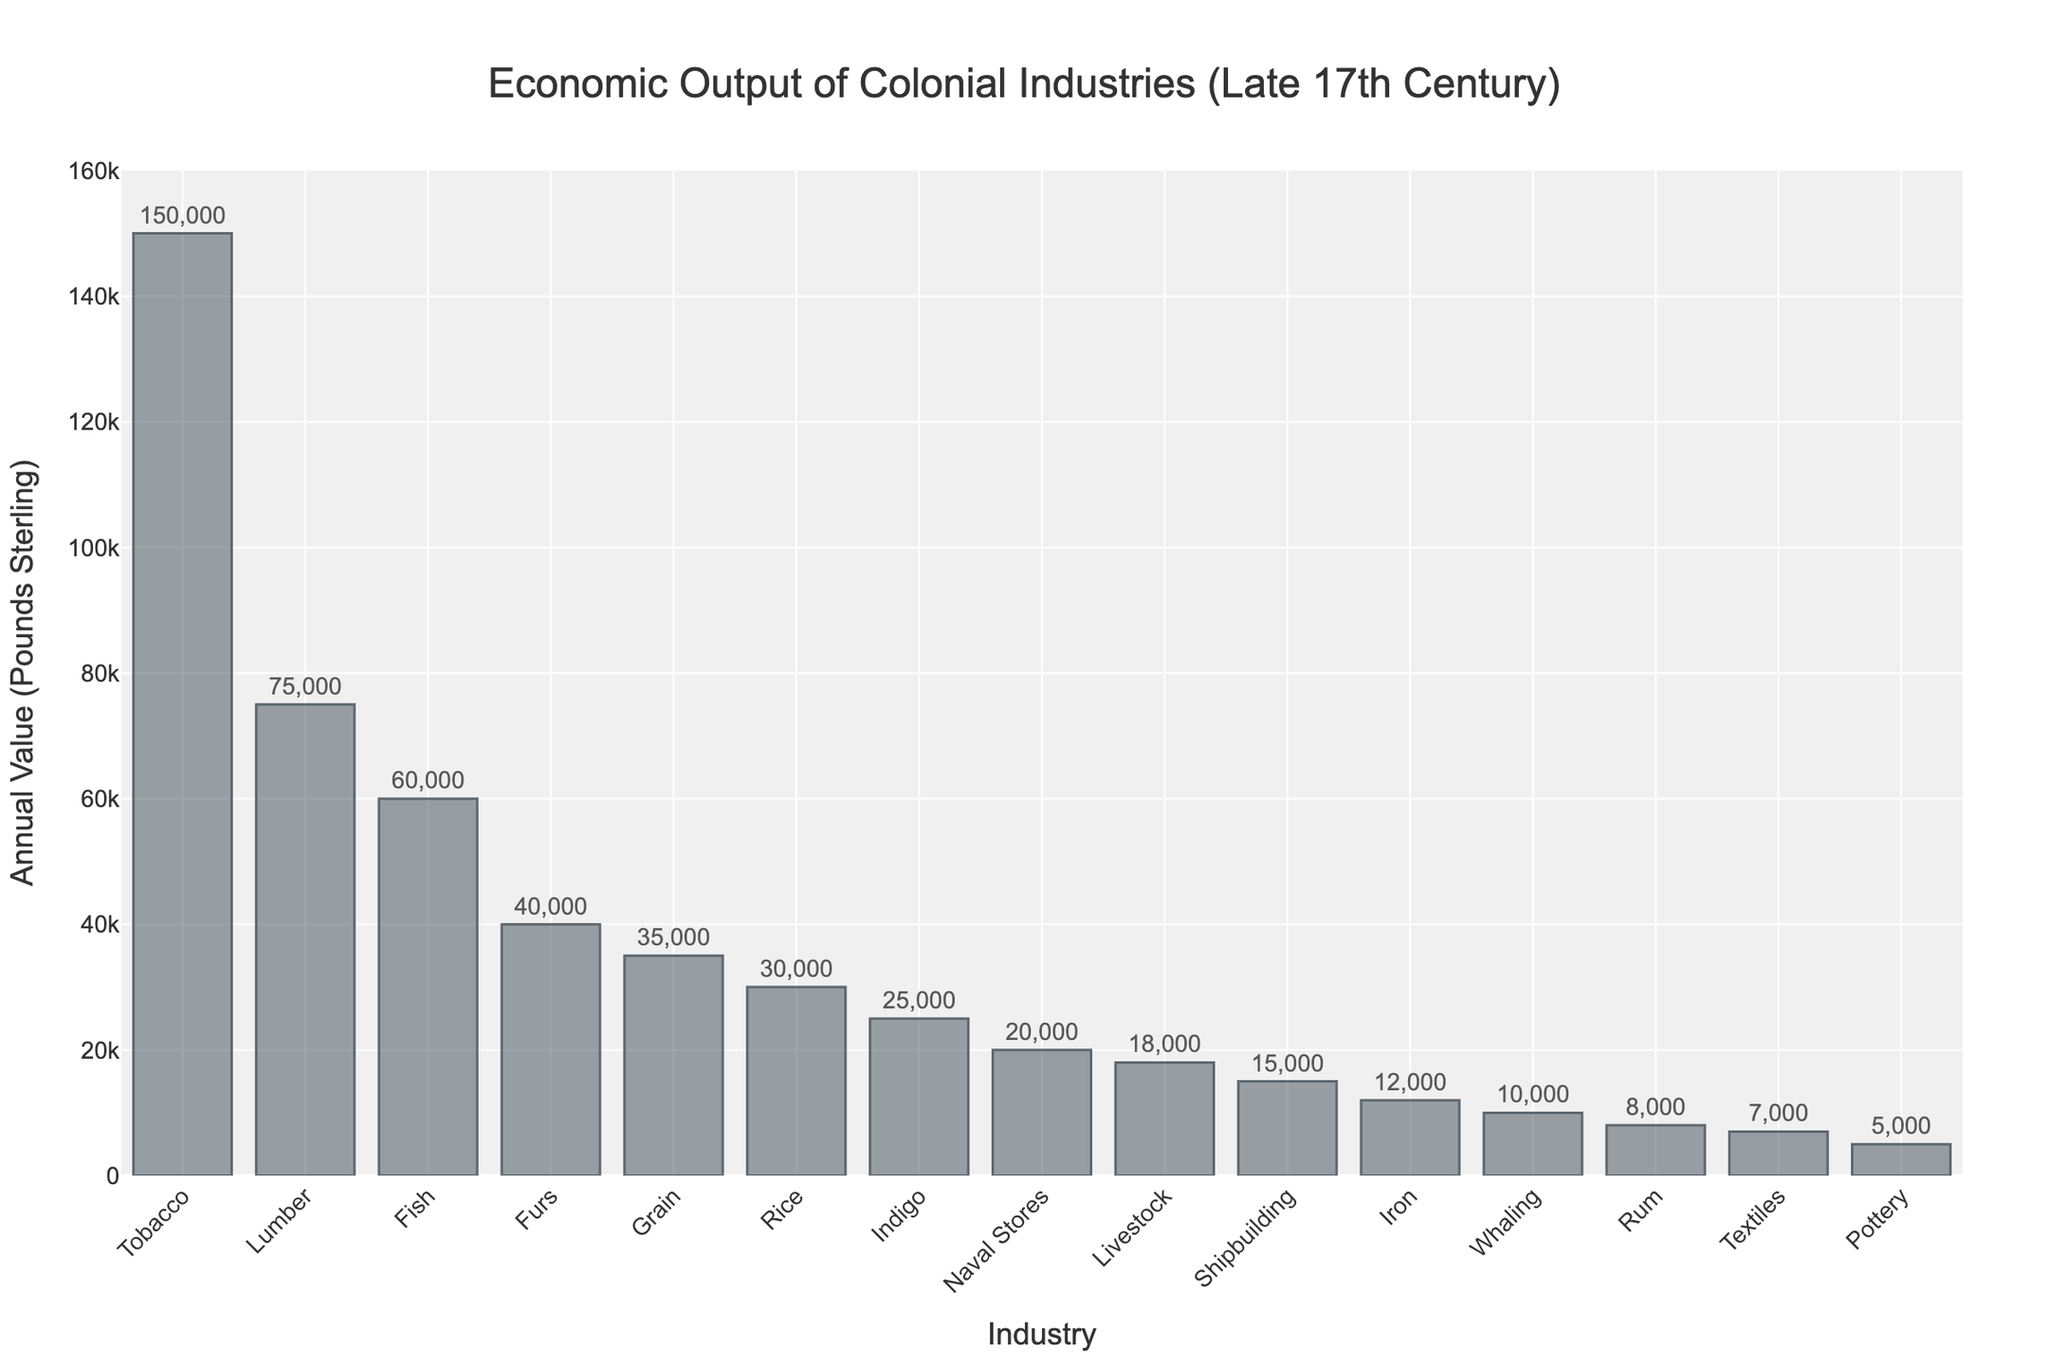Which industry had the highest economic output in the late 17th century? The tallest bar on the chart represents the industry with the highest economic output. In this case, it is Tobacco.
Answer: Tobacco What is the combined annual value of the Grain and Rice industries? To find the combined annual value, add the individual annual values of Grain (35,000) and Rice (30,000). 35,000 + 30,000 = 65,000.
Answer: 65,000 How many industries have an annual value of more than 50,000 pounds sterling? Count the bars that exceed the 50,000 mark on the y-axis. These industries are Tobacco, Lumber, and Fish. Thus, there are 3 industries.
Answer: 3 Which industry had a higher economic output, Iron or Rum? Compare the heights of the bars for Iron and Rum. Iron (12,000) and Rum (8,000), so Iron had a higher economic output.
Answer: Iron What is the total annual value of all the industries combined? Sum the annual values of all the industries:
150,000 (Tobacco) + 75,000 (Lumber) + 60,000 (Fish) + 40,000 (Furs) + 35,000 (Grain) + 30,000 (Rice) + 25,000 (Indigo) + 20,000 (Naval Stores) + 18,000 (Livestock) + 15,000 (Shipbuilding) + 12,000 (Iron) + 10,000 (Whaling) + 8,000 (Rum) + 7,000 (Textiles) + 5,000 (Pottery) = 510,000
Answer: 510,000 What is the difference in the annual value between Furs and Livestock? Subtract the annual value of Livestock (18,000) from that of Furs (40,000). 40,000 - 18,000 = 22,000.
Answer: 22,000 Which industries have an annual value less than 10,000 pounds sterling? Identify the bars that have a height corresponding to less than 10,000 pounds sterling. These industries are Rum (8,000), Textiles (7,000), and Pottery (5,000).
Answer: Rum, Textiles, Pottery What percentage of the total annual value is accounted for by the Tobacco industry? First, find the total annual value of all industries, which is 510,000. Then calculate the percentage for Tobacco: (150,000 / 510,000) * 100 ≈ 29.41%.
Answer: 29.41% Which industries have an annual value between 20,000 and 50,000 pounds sterling, inclusive? Identify the bars that fall within this range. These industries are Furs (40,000), Grain (35,000), Rice (30,000), Indigo (25,000), and Naval Stores (20,000).
Answer: Furs, Grain, Rice, Indigo, Naval Stores 